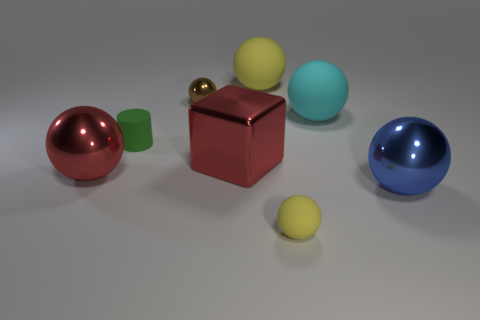Is there a tiny green matte object that has the same shape as the cyan thing?
Ensure brevity in your answer.  No. Is the number of tiny things less than the number of tiny gray shiny cylinders?
Your answer should be compact. No. Do the red object in front of the big metallic block and the yellow rubber thing that is in front of the big red metal cube have the same size?
Provide a succinct answer. No. What number of things are green metallic cubes or small green cylinders?
Your answer should be very brief. 1. How big is the yellow rubber object that is in front of the big block?
Provide a short and direct response. Small. How many large yellow rubber balls are behind the small rubber object right of the yellow thing behind the tiny green cylinder?
Keep it short and to the point. 1. Is the color of the tiny matte ball the same as the small rubber cylinder?
Ensure brevity in your answer.  No. What number of spheres are both behind the tiny rubber sphere and to the right of the cylinder?
Provide a succinct answer. 4. What shape is the large red shiny thing that is on the right side of the matte cylinder?
Provide a succinct answer. Cube. Are there fewer small yellow balls that are behind the block than metal things that are in front of the tiny brown metallic ball?
Offer a terse response. Yes. 